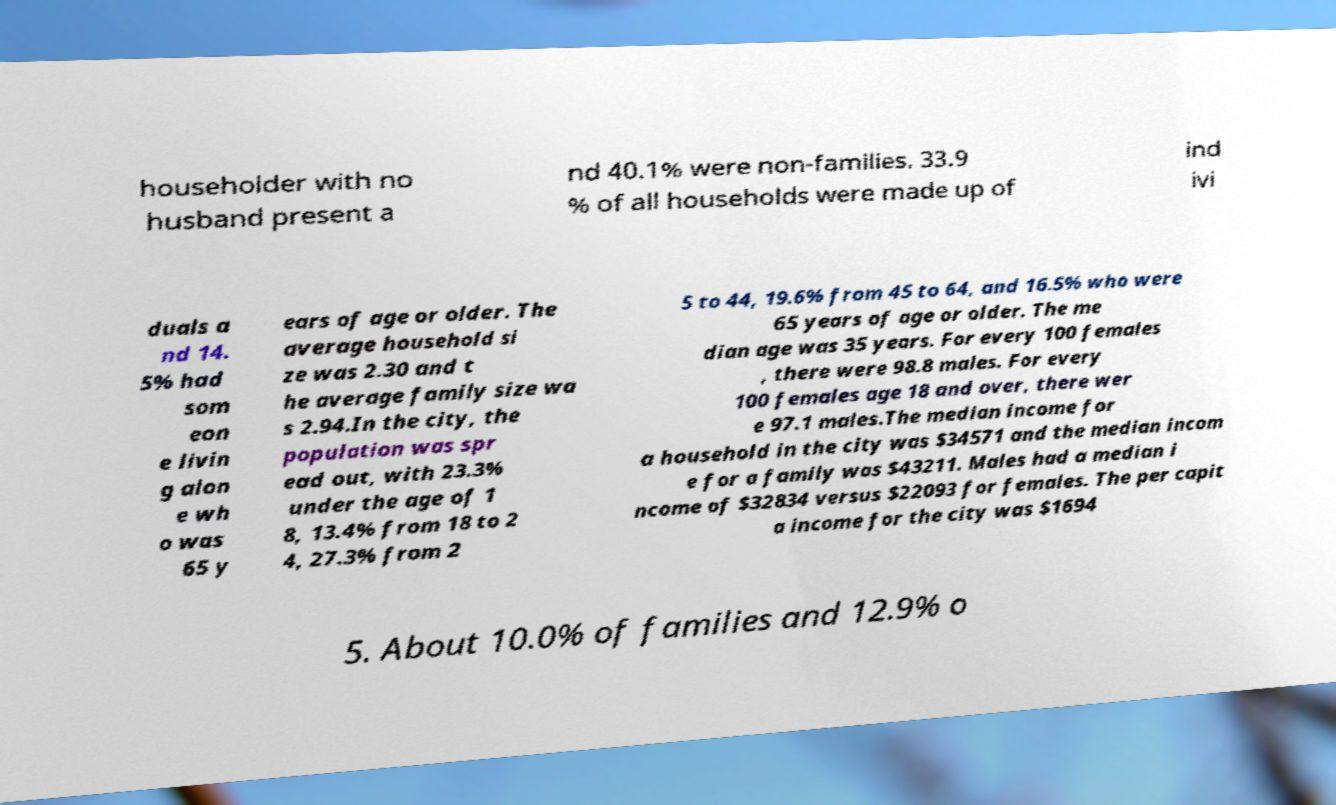Could you extract and type out the text from this image? householder with no husband present a nd 40.1% were non-families. 33.9 % of all households were made up of ind ivi duals a nd 14. 5% had som eon e livin g alon e wh o was 65 y ears of age or older. The average household si ze was 2.30 and t he average family size wa s 2.94.In the city, the population was spr ead out, with 23.3% under the age of 1 8, 13.4% from 18 to 2 4, 27.3% from 2 5 to 44, 19.6% from 45 to 64, and 16.5% who were 65 years of age or older. The me dian age was 35 years. For every 100 females , there were 98.8 males. For every 100 females age 18 and over, there wer e 97.1 males.The median income for a household in the city was $34571 and the median incom e for a family was $43211. Males had a median i ncome of $32834 versus $22093 for females. The per capit a income for the city was $1694 5. About 10.0% of families and 12.9% o 